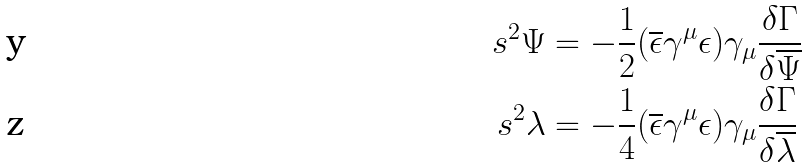Convert formula to latex. <formula><loc_0><loc_0><loc_500><loc_500>s ^ { 2 } \Psi & = - \frac { 1 } { 2 } ( \overline { \epsilon } \gamma ^ { \mu } \epsilon ) \gamma _ { \mu } \frac { \delta \Gamma } { \delta \overline { \Psi } } \\ s ^ { 2 } \lambda & = - \frac { 1 } { 4 } ( \overline { \epsilon } \gamma ^ { \mu } \epsilon ) \gamma _ { \mu } \frac { \delta \Gamma } { \delta \overline { \lambda } }</formula> 